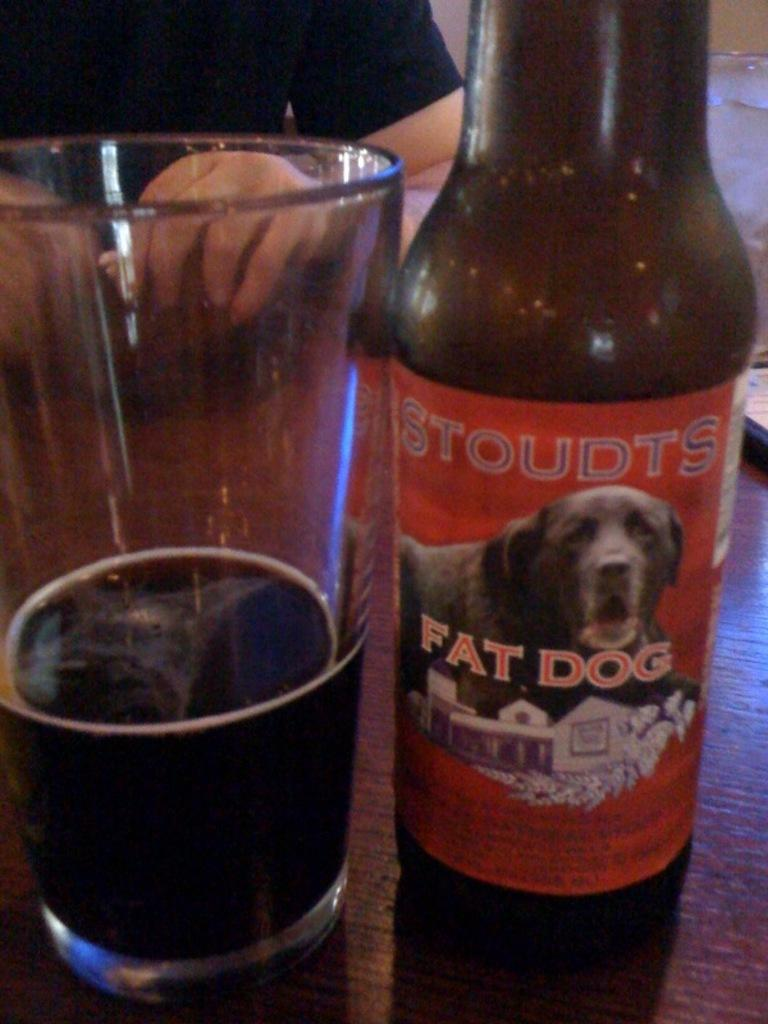<image>
Write a terse but informative summary of the picture. A half full glass next to a bottle of Stoudts Fat Dog. 